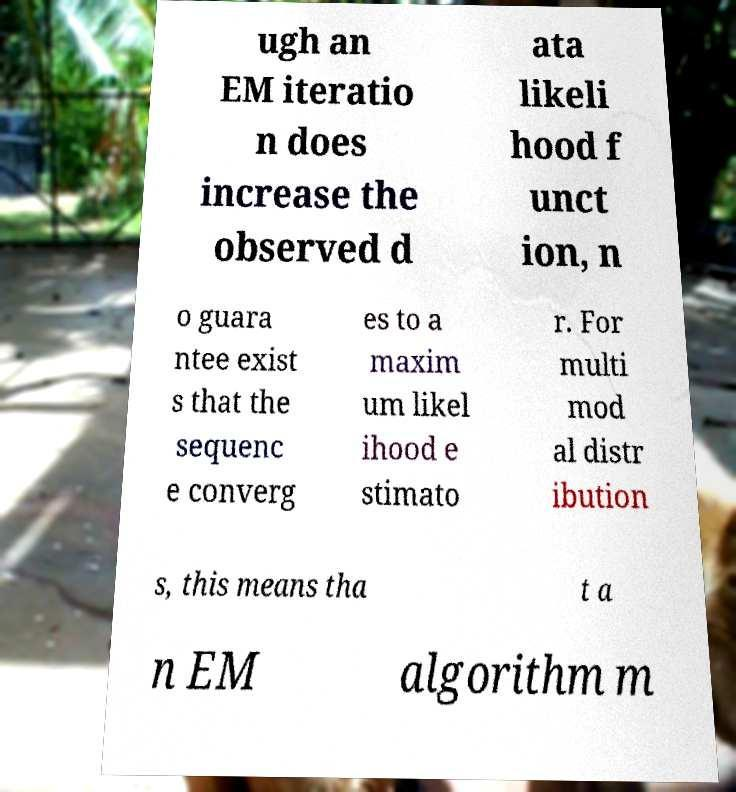Can you read and provide the text displayed in the image?This photo seems to have some interesting text. Can you extract and type it out for me? ugh an EM iteratio n does increase the observed d ata likeli hood f unct ion, n o guara ntee exist s that the sequenc e converg es to a maxim um likel ihood e stimato r. For multi mod al distr ibution s, this means tha t a n EM algorithm m 